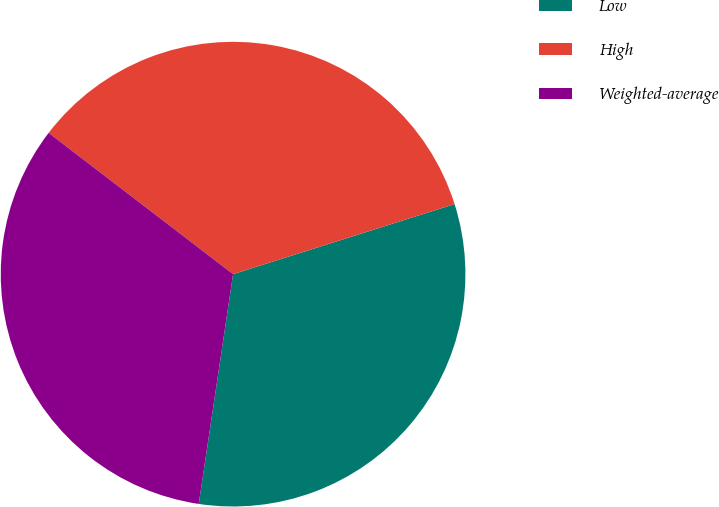<chart> <loc_0><loc_0><loc_500><loc_500><pie_chart><fcel>Low<fcel>High<fcel>Weighted-average<nl><fcel>32.24%<fcel>34.72%<fcel>33.04%<nl></chart> 